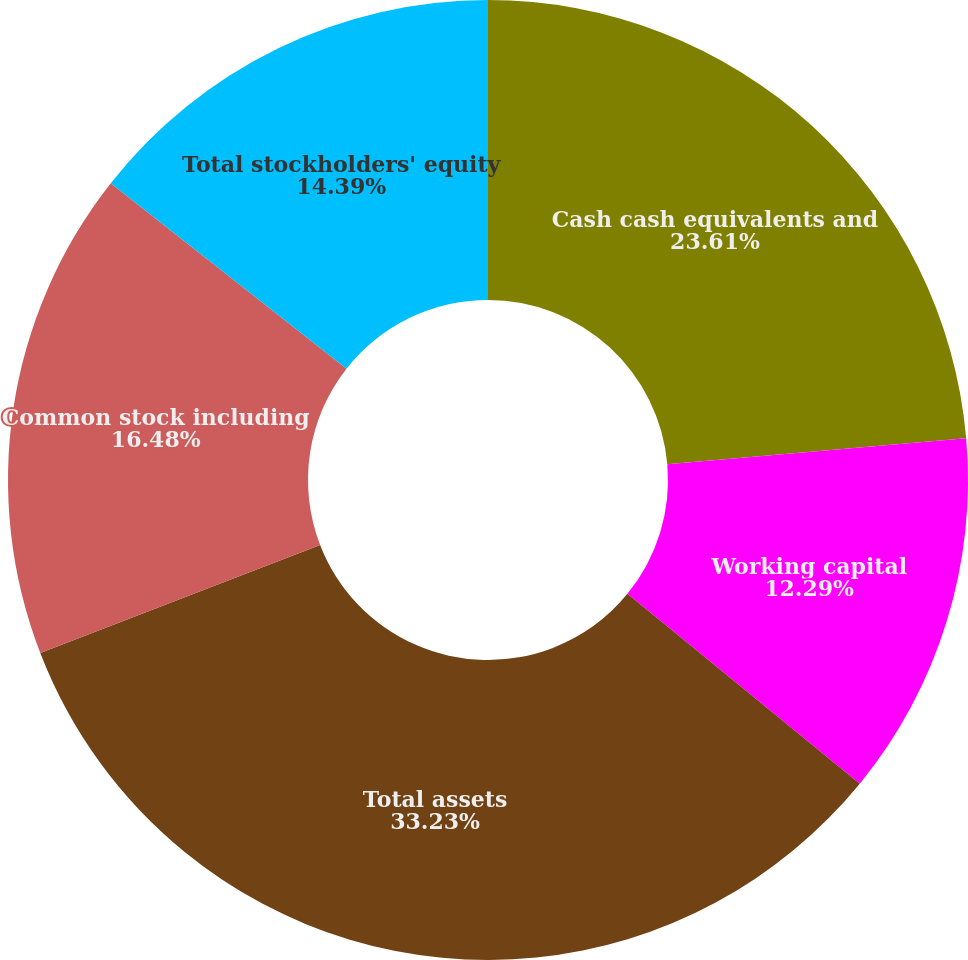<chart> <loc_0><loc_0><loc_500><loc_500><pie_chart><fcel>Cash cash equivalents and<fcel>Working capital<fcel>Total assets<fcel>Common stock including<fcel>Total stockholders' equity<nl><fcel>23.61%<fcel>12.29%<fcel>33.23%<fcel>16.48%<fcel>14.39%<nl></chart> 